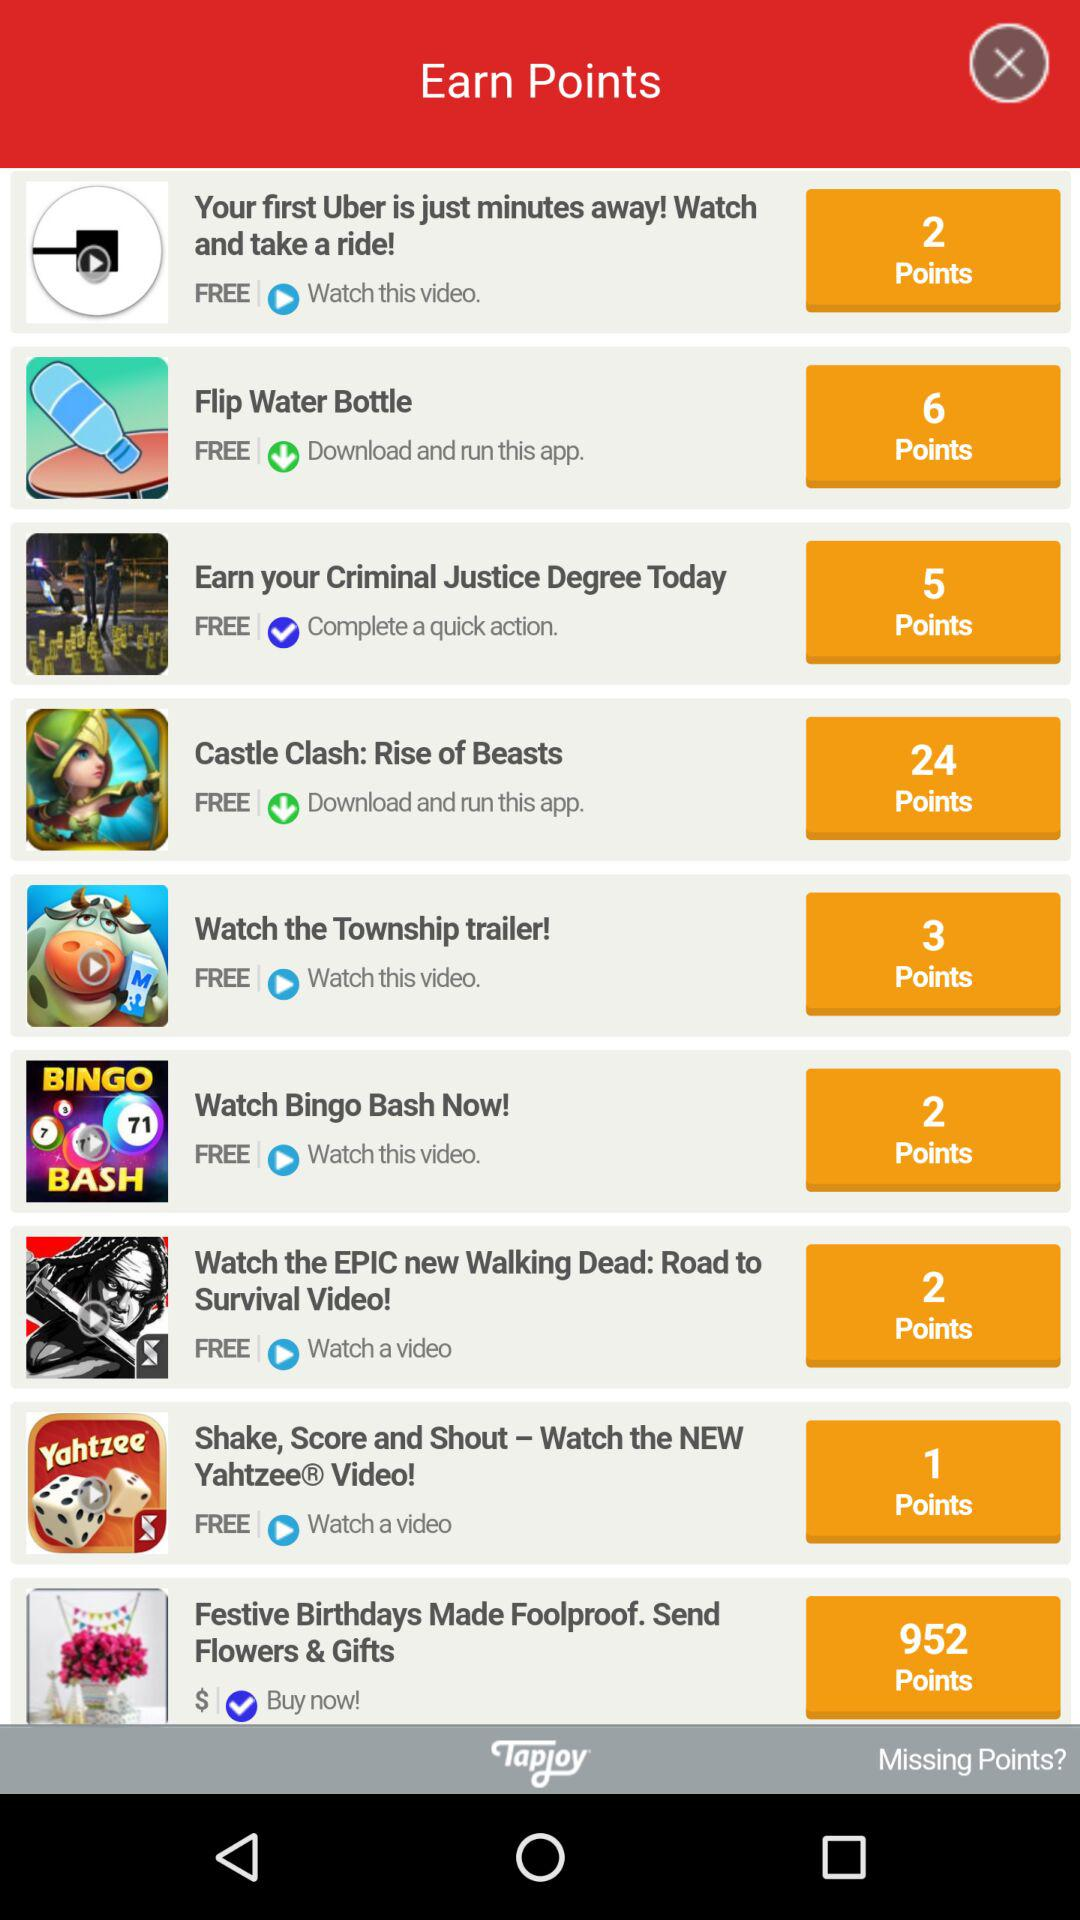How many points can be earned if "Flip Water Bottle" is downloaded? The points that can be earned are 6. 